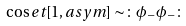<formula> <loc_0><loc_0><loc_500><loc_500>\cos e t [ 1 , a s y m ] \sim \colon \phi _ { - } \phi _ { - } \colon</formula> 